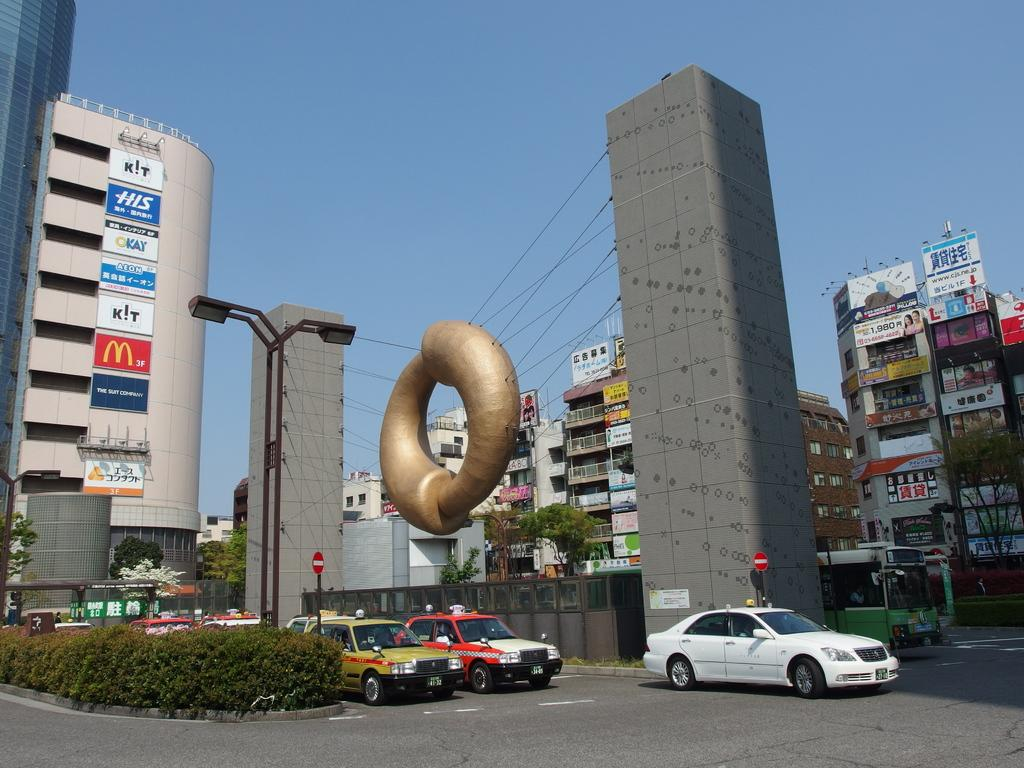<image>
Give a short and clear explanation of the subsequent image. a building with the word Kay on one of the posters 